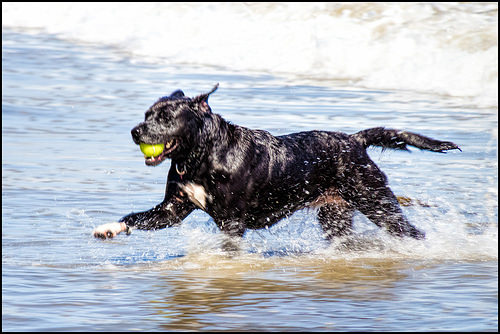<image>
Is there a dog in the water? Yes. The dog is contained within or inside the water, showing a containment relationship. 